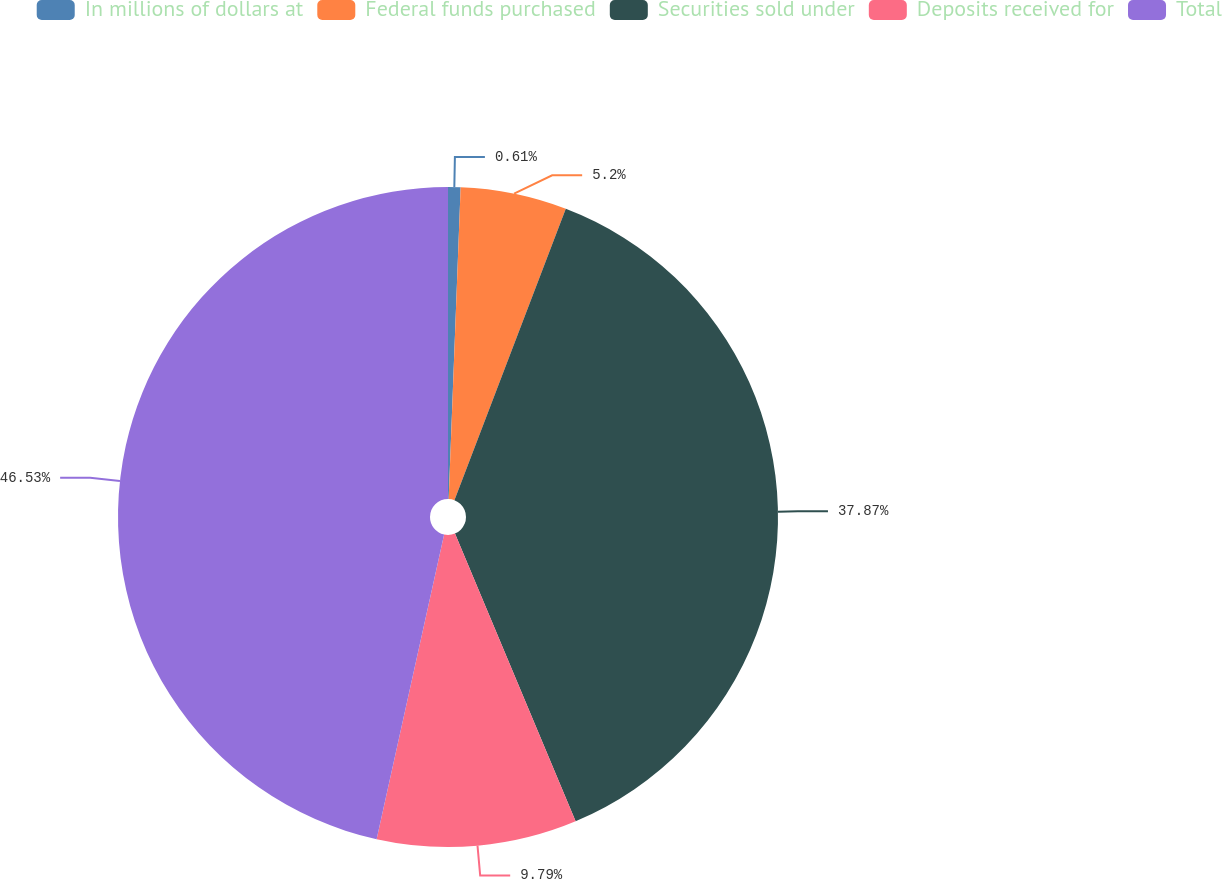Convert chart. <chart><loc_0><loc_0><loc_500><loc_500><pie_chart><fcel>In millions of dollars at<fcel>Federal funds purchased<fcel>Securities sold under<fcel>Deposits received for<fcel>Total<nl><fcel>0.61%<fcel>5.2%<fcel>37.87%<fcel>9.79%<fcel>46.53%<nl></chart> 